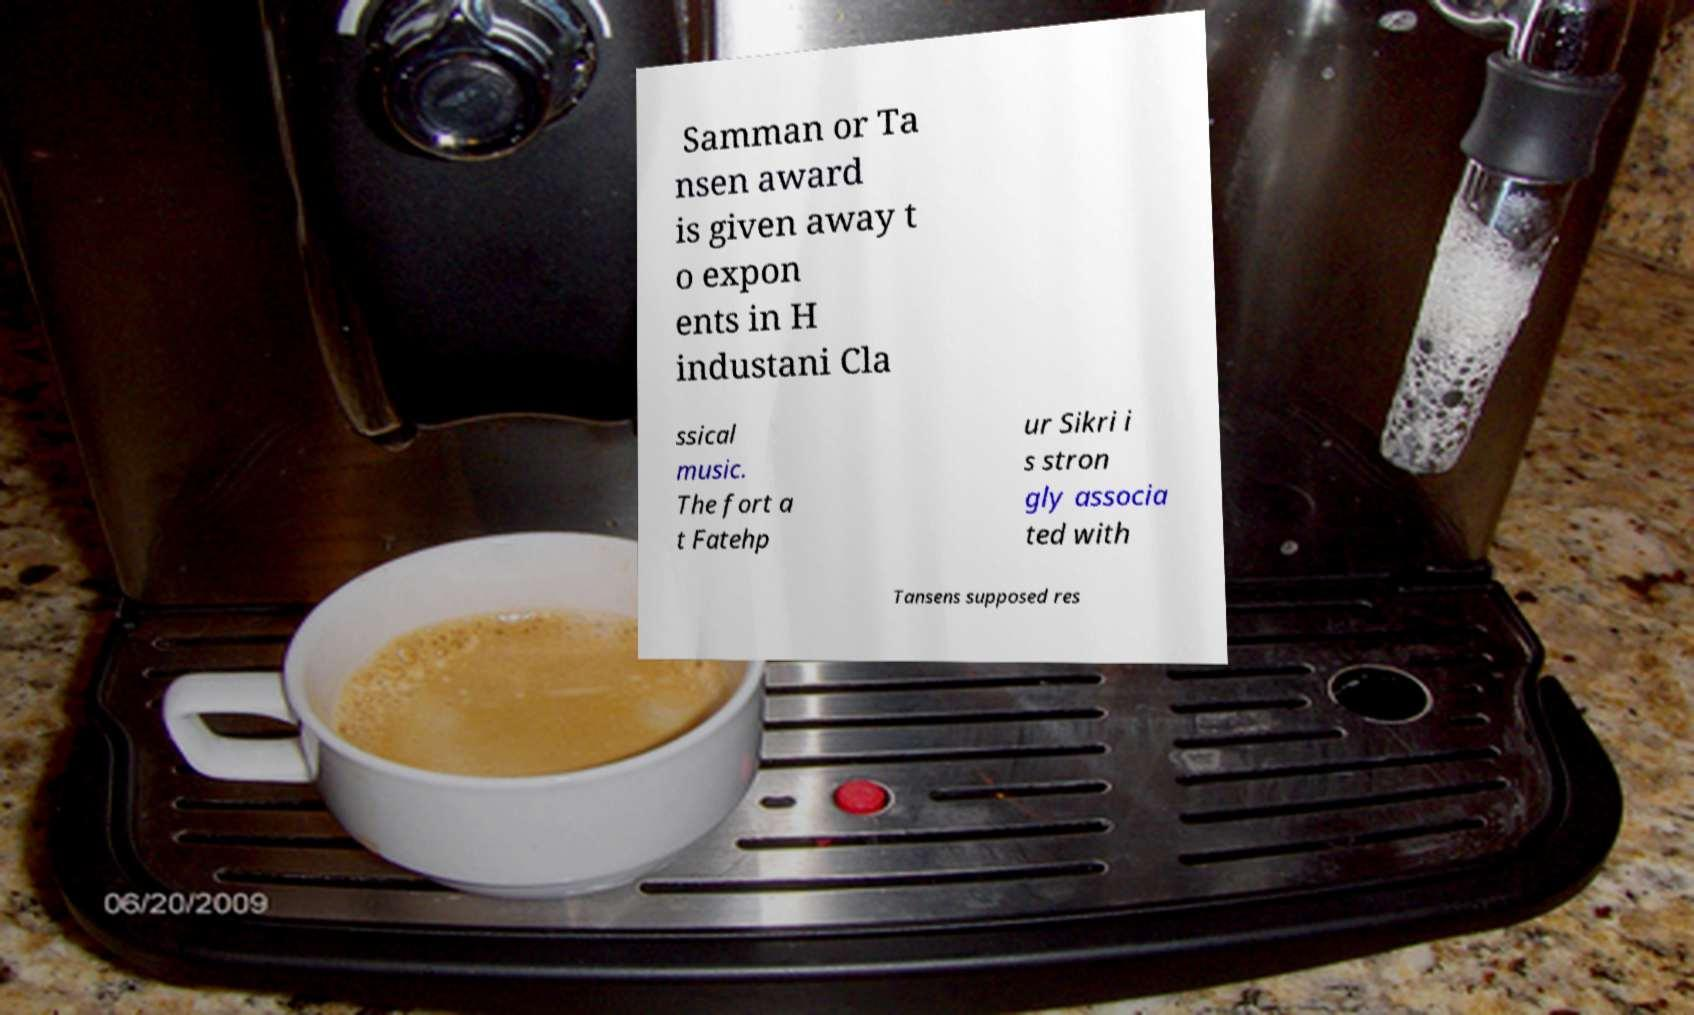Please read and relay the text visible in this image. What does it say? Samman or Ta nsen award is given away t o expon ents in H industani Cla ssical music. The fort a t Fatehp ur Sikri i s stron gly associa ted with Tansens supposed res 